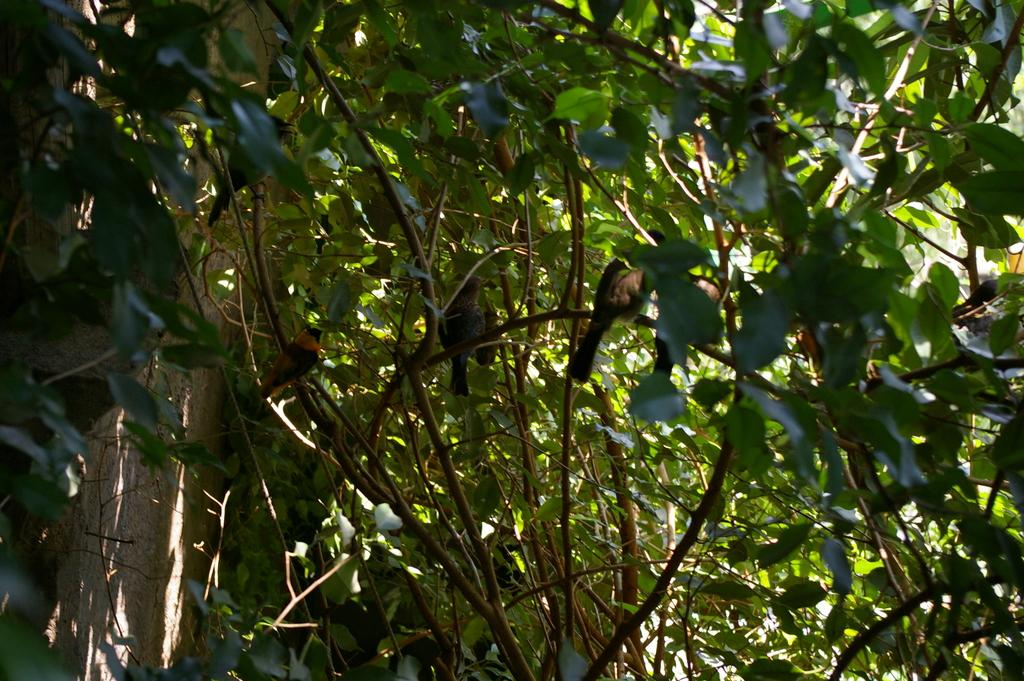What type of animals can be seen in the image? There are birds in the image. Where are the birds located in the image? The birds are sitting on a tree. What colors are the birds in the image? The birds are in black and brown colors. What color is the tree in the image? The tree is in green color. What type of fruit can be seen hanging from the tree in the image? There is no fruit visible in the image; only birds are present on the tree. How many cats are sitting on the tree with the birds in the image? There are no cats present in the image; only birds are sitting on the tree. 